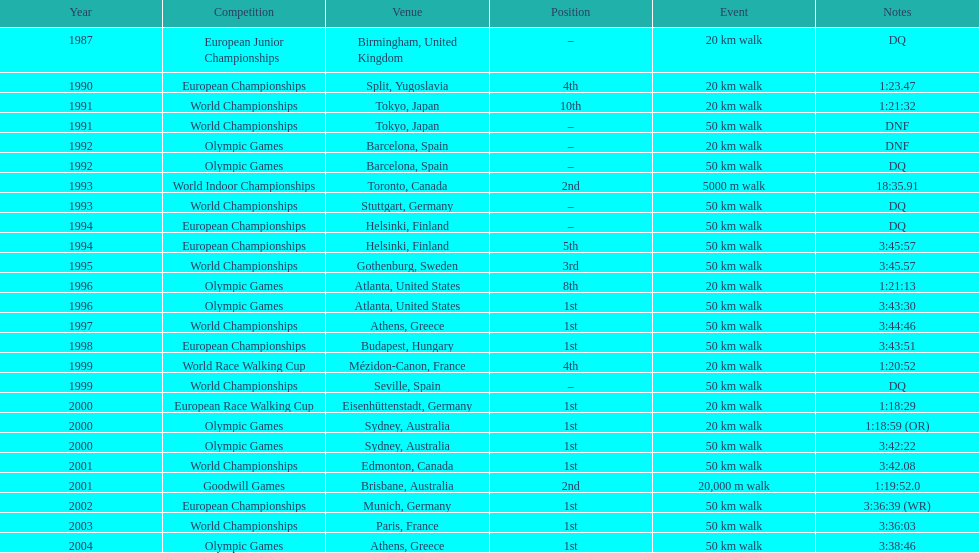How many times was korzeniowski disqualified from a competition? 5. 